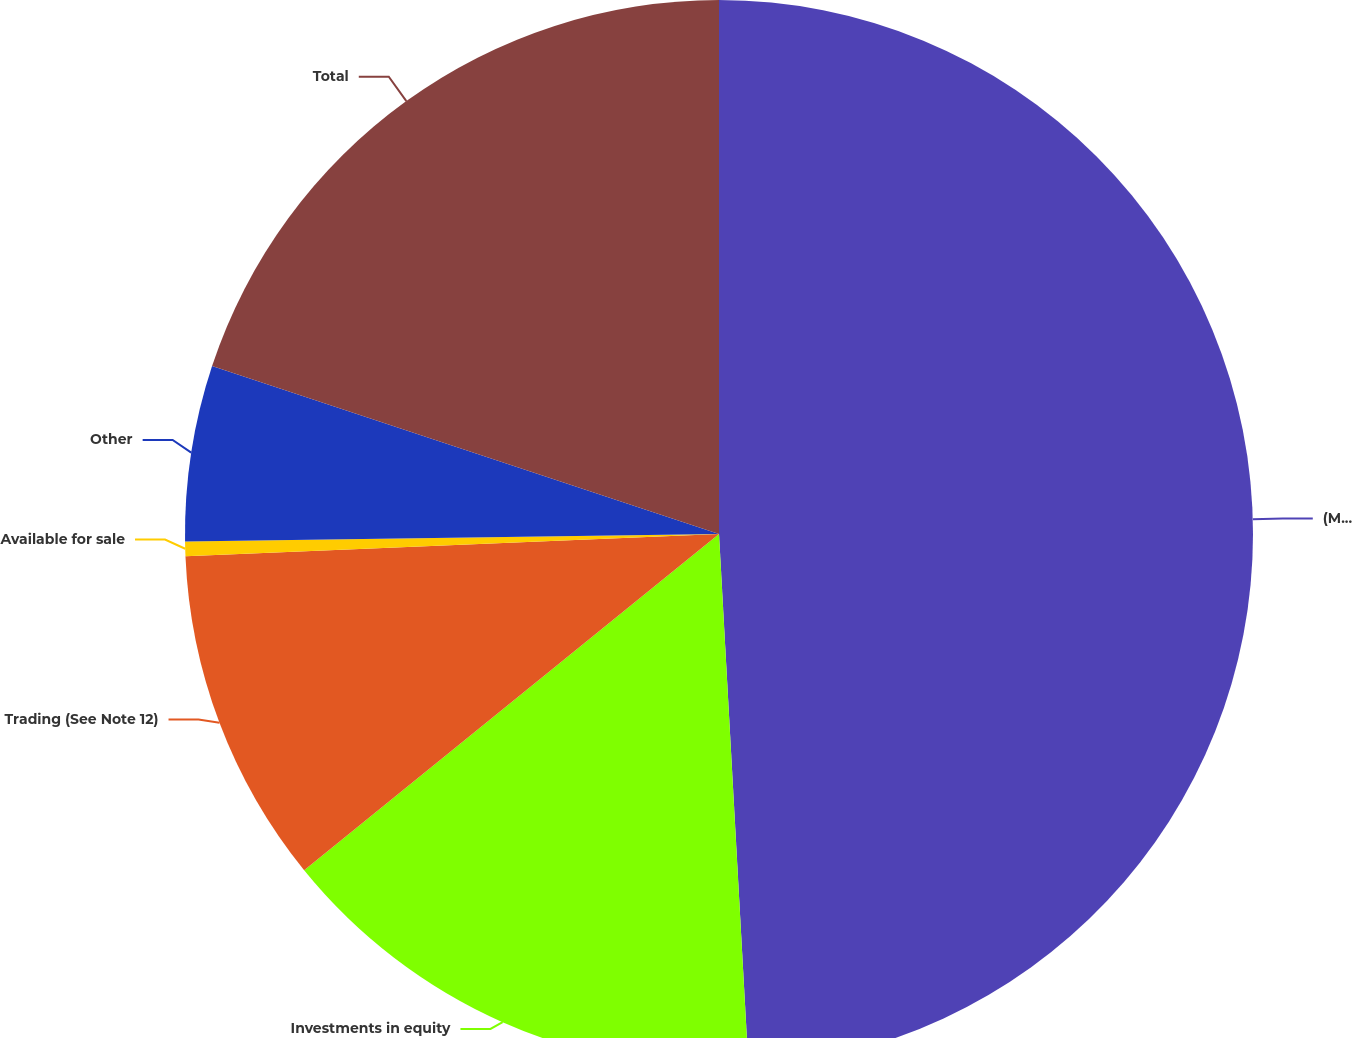Convert chart. <chart><loc_0><loc_0><loc_500><loc_500><pie_chart><fcel>(Millions)<fcel>Investments in equity<fcel>Trading (See Note 12)<fcel>Available for sale<fcel>Other<fcel>Total<nl><fcel>49.12%<fcel>15.04%<fcel>10.18%<fcel>0.44%<fcel>5.31%<fcel>19.91%<nl></chart> 